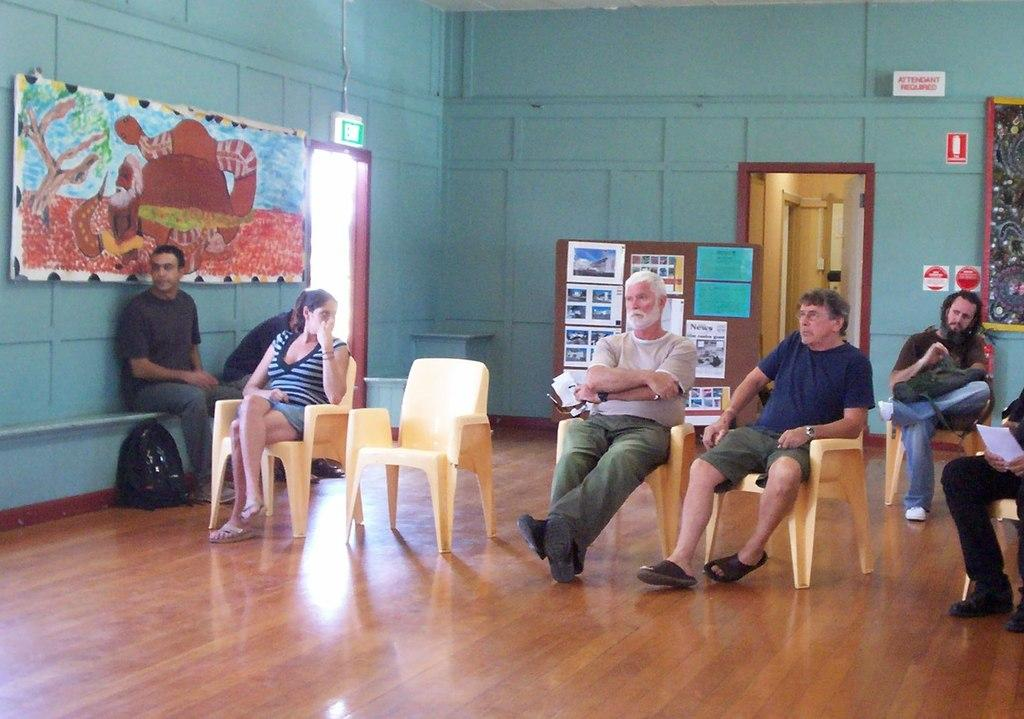What are the people in the image doing? The people in the image are sitting on chairs. What can be seen on the left wall in the image? There is a painting on the left wall in the image. What is located at the back of the people in the image? There is a display board at the back of the people in the image. What is on the display board? There are notices on the display board. What type of poison is being used to clean the painting in the image? There is no indication of any poison being used in the image; the painting is simply hanging on the wall. 